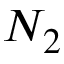<formula> <loc_0><loc_0><loc_500><loc_500>N _ { 2 }</formula> 